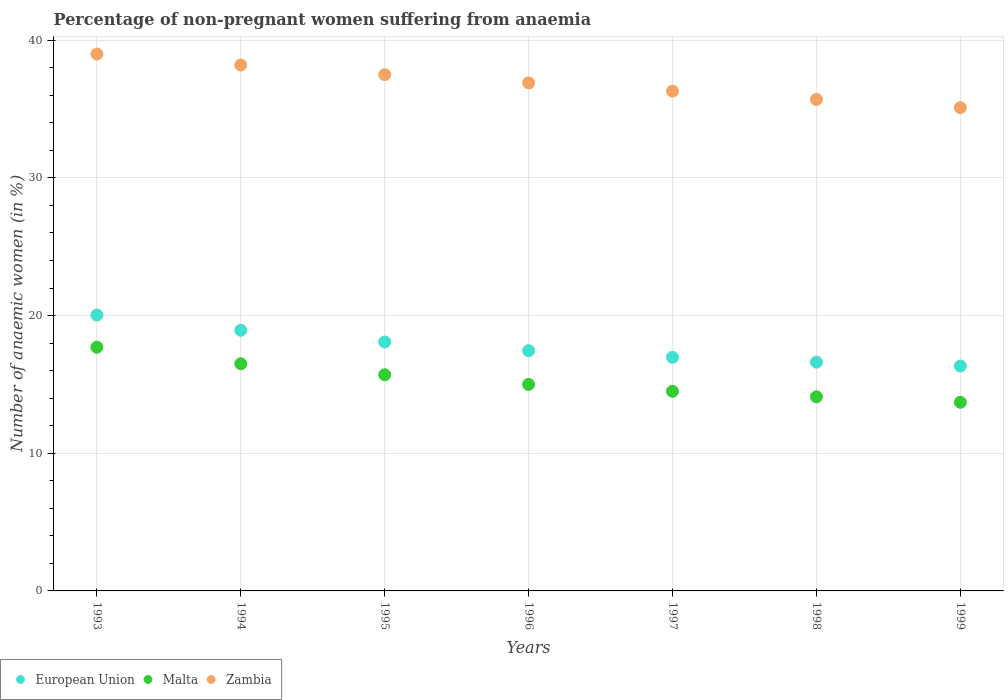How many different coloured dotlines are there?
Provide a succinct answer. 3. Is the number of dotlines equal to the number of legend labels?
Give a very brief answer. Yes. What is the percentage of non-pregnant women suffering from anaemia in Zambia in 1996?
Give a very brief answer. 36.9. Across all years, what is the minimum percentage of non-pregnant women suffering from anaemia in European Union?
Your response must be concise. 16.34. In which year was the percentage of non-pregnant women suffering from anaemia in Malta minimum?
Offer a very short reply. 1999. What is the total percentage of non-pregnant women suffering from anaemia in Zambia in the graph?
Offer a terse response. 258.7. What is the difference between the percentage of non-pregnant women suffering from anaemia in Malta in 1993 and that in 1997?
Provide a succinct answer. 3.2. What is the difference between the percentage of non-pregnant women suffering from anaemia in Malta in 1998 and the percentage of non-pregnant women suffering from anaemia in Zambia in 1996?
Provide a succinct answer. -22.8. What is the average percentage of non-pregnant women suffering from anaemia in Malta per year?
Offer a terse response. 15.31. In the year 1994, what is the difference between the percentage of non-pregnant women suffering from anaemia in Malta and percentage of non-pregnant women suffering from anaemia in Zambia?
Your response must be concise. -21.7. What is the ratio of the percentage of non-pregnant women suffering from anaemia in Malta in 1998 to that in 1999?
Provide a succinct answer. 1.03. Is the percentage of non-pregnant women suffering from anaemia in Zambia in 1996 less than that in 1999?
Offer a very short reply. No. Is the difference between the percentage of non-pregnant women suffering from anaemia in Malta in 1996 and 1999 greater than the difference between the percentage of non-pregnant women suffering from anaemia in Zambia in 1996 and 1999?
Ensure brevity in your answer.  No. What is the difference between the highest and the second highest percentage of non-pregnant women suffering from anaemia in Zambia?
Your response must be concise. 0.8. What is the difference between the highest and the lowest percentage of non-pregnant women suffering from anaemia in European Union?
Offer a terse response. 3.7. In how many years, is the percentage of non-pregnant women suffering from anaemia in European Union greater than the average percentage of non-pregnant women suffering from anaemia in European Union taken over all years?
Ensure brevity in your answer.  3. Is the sum of the percentage of non-pregnant women suffering from anaemia in European Union in 1995 and 1999 greater than the maximum percentage of non-pregnant women suffering from anaemia in Zambia across all years?
Your answer should be compact. No. Is it the case that in every year, the sum of the percentage of non-pregnant women suffering from anaemia in Zambia and percentage of non-pregnant women suffering from anaemia in Malta  is greater than the percentage of non-pregnant women suffering from anaemia in European Union?
Provide a succinct answer. Yes. Does the percentage of non-pregnant women suffering from anaemia in European Union monotonically increase over the years?
Offer a very short reply. No. Is the percentage of non-pregnant women suffering from anaemia in Zambia strictly less than the percentage of non-pregnant women suffering from anaemia in Malta over the years?
Your answer should be compact. No. How many dotlines are there?
Your answer should be very brief. 3. What is the difference between two consecutive major ticks on the Y-axis?
Offer a terse response. 10. Does the graph contain grids?
Your response must be concise. Yes. How many legend labels are there?
Make the answer very short. 3. What is the title of the graph?
Keep it short and to the point. Percentage of non-pregnant women suffering from anaemia. Does "Eritrea" appear as one of the legend labels in the graph?
Offer a very short reply. No. What is the label or title of the Y-axis?
Offer a terse response. Number of anaemic women (in %). What is the Number of anaemic women (in %) in European Union in 1993?
Your answer should be very brief. 20.04. What is the Number of anaemic women (in %) in Malta in 1993?
Provide a short and direct response. 17.7. What is the Number of anaemic women (in %) in European Union in 1994?
Provide a succinct answer. 18.93. What is the Number of anaemic women (in %) of Zambia in 1994?
Offer a terse response. 38.2. What is the Number of anaemic women (in %) in European Union in 1995?
Make the answer very short. 18.08. What is the Number of anaemic women (in %) of Zambia in 1995?
Give a very brief answer. 37.5. What is the Number of anaemic women (in %) in European Union in 1996?
Ensure brevity in your answer.  17.45. What is the Number of anaemic women (in %) of Malta in 1996?
Provide a short and direct response. 15. What is the Number of anaemic women (in %) of Zambia in 1996?
Offer a very short reply. 36.9. What is the Number of anaemic women (in %) in European Union in 1997?
Ensure brevity in your answer.  16.97. What is the Number of anaemic women (in %) of Zambia in 1997?
Give a very brief answer. 36.3. What is the Number of anaemic women (in %) in European Union in 1998?
Provide a succinct answer. 16.62. What is the Number of anaemic women (in %) in Malta in 1998?
Provide a short and direct response. 14.1. What is the Number of anaemic women (in %) in Zambia in 1998?
Ensure brevity in your answer.  35.7. What is the Number of anaemic women (in %) in European Union in 1999?
Provide a short and direct response. 16.34. What is the Number of anaemic women (in %) of Malta in 1999?
Offer a terse response. 13.7. What is the Number of anaemic women (in %) of Zambia in 1999?
Provide a succinct answer. 35.1. Across all years, what is the maximum Number of anaemic women (in %) in European Union?
Provide a succinct answer. 20.04. Across all years, what is the minimum Number of anaemic women (in %) in European Union?
Give a very brief answer. 16.34. Across all years, what is the minimum Number of anaemic women (in %) in Zambia?
Your answer should be very brief. 35.1. What is the total Number of anaemic women (in %) of European Union in the graph?
Offer a terse response. 124.42. What is the total Number of anaemic women (in %) of Malta in the graph?
Your answer should be very brief. 107.2. What is the total Number of anaemic women (in %) in Zambia in the graph?
Provide a short and direct response. 258.7. What is the difference between the Number of anaemic women (in %) in European Union in 1993 and that in 1994?
Provide a short and direct response. 1.11. What is the difference between the Number of anaemic women (in %) in Malta in 1993 and that in 1994?
Offer a very short reply. 1.2. What is the difference between the Number of anaemic women (in %) in European Union in 1993 and that in 1995?
Provide a succinct answer. 1.96. What is the difference between the Number of anaemic women (in %) in Malta in 1993 and that in 1995?
Ensure brevity in your answer.  2. What is the difference between the Number of anaemic women (in %) in European Union in 1993 and that in 1996?
Your answer should be very brief. 2.59. What is the difference between the Number of anaemic women (in %) in Malta in 1993 and that in 1996?
Offer a terse response. 2.7. What is the difference between the Number of anaemic women (in %) in European Union in 1993 and that in 1997?
Your response must be concise. 3.07. What is the difference between the Number of anaemic women (in %) in Zambia in 1993 and that in 1997?
Provide a short and direct response. 2.7. What is the difference between the Number of anaemic women (in %) of European Union in 1993 and that in 1998?
Provide a short and direct response. 3.42. What is the difference between the Number of anaemic women (in %) in European Union in 1993 and that in 1999?
Offer a terse response. 3.7. What is the difference between the Number of anaemic women (in %) in Malta in 1993 and that in 1999?
Ensure brevity in your answer.  4. What is the difference between the Number of anaemic women (in %) of European Union in 1994 and that in 1995?
Provide a short and direct response. 0.85. What is the difference between the Number of anaemic women (in %) in Malta in 1994 and that in 1995?
Ensure brevity in your answer.  0.8. What is the difference between the Number of anaemic women (in %) in Zambia in 1994 and that in 1995?
Provide a short and direct response. 0.7. What is the difference between the Number of anaemic women (in %) in European Union in 1994 and that in 1996?
Offer a very short reply. 1.48. What is the difference between the Number of anaemic women (in %) in Malta in 1994 and that in 1996?
Provide a succinct answer. 1.5. What is the difference between the Number of anaemic women (in %) of European Union in 1994 and that in 1997?
Provide a succinct answer. 1.97. What is the difference between the Number of anaemic women (in %) of European Union in 1994 and that in 1998?
Your answer should be compact. 2.32. What is the difference between the Number of anaemic women (in %) in Malta in 1994 and that in 1998?
Provide a short and direct response. 2.4. What is the difference between the Number of anaemic women (in %) of Zambia in 1994 and that in 1998?
Keep it short and to the point. 2.5. What is the difference between the Number of anaemic women (in %) in European Union in 1994 and that in 1999?
Your response must be concise. 2.6. What is the difference between the Number of anaemic women (in %) in Malta in 1994 and that in 1999?
Give a very brief answer. 2.8. What is the difference between the Number of anaemic women (in %) of Zambia in 1994 and that in 1999?
Offer a very short reply. 3.1. What is the difference between the Number of anaemic women (in %) in European Union in 1995 and that in 1996?
Your response must be concise. 0.63. What is the difference between the Number of anaemic women (in %) of European Union in 1995 and that in 1997?
Offer a very short reply. 1.12. What is the difference between the Number of anaemic women (in %) in Malta in 1995 and that in 1997?
Your response must be concise. 1.2. What is the difference between the Number of anaemic women (in %) of European Union in 1995 and that in 1998?
Provide a short and direct response. 1.46. What is the difference between the Number of anaemic women (in %) in European Union in 1995 and that in 1999?
Your response must be concise. 1.75. What is the difference between the Number of anaemic women (in %) of Malta in 1995 and that in 1999?
Keep it short and to the point. 2. What is the difference between the Number of anaemic women (in %) in Zambia in 1995 and that in 1999?
Give a very brief answer. 2.4. What is the difference between the Number of anaemic women (in %) in European Union in 1996 and that in 1997?
Offer a very short reply. 0.48. What is the difference between the Number of anaemic women (in %) in Malta in 1996 and that in 1997?
Offer a very short reply. 0.5. What is the difference between the Number of anaemic women (in %) in Zambia in 1996 and that in 1997?
Your response must be concise. 0.6. What is the difference between the Number of anaemic women (in %) of European Union in 1996 and that in 1998?
Offer a terse response. 0.83. What is the difference between the Number of anaemic women (in %) of Zambia in 1996 and that in 1998?
Your answer should be very brief. 1.2. What is the difference between the Number of anaemic women (in %) of European Union in 1996 and that in 1999?
Provide a succinct answer. 1.11. What is the difference between the Number of anaemic women (in %) of European Union in 1997 and that in 1998?
Your answer should be very brief. 0.35. What is the difference between the Number of anaemic women (in %) of Zambia in 1997 and that in 1998?
Keep it short and to the point. 0.6. What is the difference between the Number of anaemic women (in %) of European Union in 1997 and that in 1999?
Keep it short and to the point. 0.63. What is the difference between the Number of anaemic women (in %) of Zambia in 1997 and that in 1999?
Your answer should be compact. 1.2. What is the difference between the Number of anaemic women (in %) in European Union in 1998 and that in 1999?
Provide a succinct answer. 0.28. What is the difference between the Number of anaemic women (in %) of Malta in 1998 and that in 1999?
Ensure brevity in your answer.  0.4. What is the difference between the Number of anaemic women (in %) in Zambia in 1998 and that in 1999?
Provide a short and direct response. 0.6. What is the difference between the Number of anaemic women (in %) of European Union in 1993 and the Number of anaemic women (in %) of Malta in 1994?
Offer a terse response. 3.54. What is the difference between the Number of anaemic women (in %) in European Union in 1993 and the Number of anaemic women (in %) in Zambia in 1994?
Your response must be concise. -18.16. What is the difference between the Number of anaemic women (in %) of Malta in 1993 and the Number of anaemic women (in %) of Zambia in 1994?
Ensure brevity in your answer.  -20.5. What is the difference between the Number of anaemic women (in %) of European Union in 1993 and the Number of anaemic women (in %) of Malta in 1995?
Keep it short and to the point. 4.34. What is the difference between the Number of anaemic women (in %) in European Union in 1993 and the Number of anaemic women (in %) in Zambia in 1995?
Provide a succinct answer. -17.46. What is the difference between the Number of anaemic women (in %) of Malta in 1993 and the Number of anaemic women (in %) of Zambia in 1995?
Make the answer very short. -19.8. What is the difference between the Number of anaemic women (in %) of European Union in 1993 and the Number of anaemic women (in %) of Malta in 1996?
Make the answer very short. 5.04. What is the difference between the Number of anaemic women (in %) in European Union in 1993 and the Number of anaemic women (in %) in Zambia in 1996?
Your answer should be very brief. -16.86. What is the difference between the Number of anaemic women (in %) of Malta in 1993 and the Number of anaemic women (in %) of Zambia in 1996?
Provide a succinct answer. -19.2. What is the difference between the Number of anaemic women (in %) in European Union in 1993 and the Number of anaemic women (in %) in Malta in 1997?
Make the answer very short. 5.54. What is the difference between the Number of anaemic women (in %) of European Union in 1993 and the Number of anaemic women (in %) of Zambia in 1997?
Offer a terse response. -16.26. What is the difference between the Number of anaemic women (in %) of Malta in 1993 and the Number of anaemic women (in %) of Zambia in 1997?
Your response must be concise. -18.6. What is the difference between the Number of anaemic women (in %) in European Union in 1993 and the Number of anaemic women (in %) in Malta in 1998?
Make the answer very short. 5.94. What is the difference between the Number of anaemic women (in %) in European Union in 1993 and the Number of anaemic women (in %) in Zambia in 1998?
Offer a very short reply. -15.66. What is the difference between the Number of anaemic women (in %) in Malta in 1993 and the Number of anaemic women (in %) in Zambia in 1998?
Your answer should be very brief. -18. What is the difference between the Number of anaemic women (in %) in European Union in 1993 and the Number of anaemic women (in %) in Malta in 1999?
Provide a short and direct response. 6.34. What is the difference between the Number of anaemic women (in %) in European Union in 1993 and the Number of anaemic women (in %) in Zambia in 1999?
Offer a terse response. -15.06. What is the difference between the Number of anaemic women (in %) in Malta in 1993 and the Number of anaemic women (in %) in Zambia in 1999?
Offer a terse response. -17.4. What is the difference between the Number of anaemic women (in %) in European Union in 1994 and the Number of anaemic women (in %) in Malta in 1995?
Your response must be concise. 3.23. What is the difference between the Number of anaemic women (in %) in European Union in 1994 and the Number of anaemic women (in %) in Zambia in 1995?
Provide a succinct answer. -18.57. What is the difference between the Number of anaemic women (in %) in Malta in 1994 and the Number of anaemic women (in %) in Zambia in 1995?
Provide a short and direct response. -21. What is the difference between the Number of anaemic women (in %) of European Union in 1994 and the Number of anaemic women (in %) of Malta in 1996?
Your answer should be very brief. 3.93. What is the difference between the Number of anaemic women (in %) in European Union in 1994 and the Number of anaemic women (in %) in Zambia in 1996?
Provide a succinct answer. -17.97. What is the difference between the Number of anaemic women (in %) in Malta in 1994 and the Number of anaemic women (in %) in Zambia in 1996?
Offer a terse response. -20.4. What is the difference between the Number of anaemic women (in %) in European Union in 1994 and the Number of anaemic women (in %) in Malta in 1997?
Make the answer very short. 4.43. What is the difference between the Number of anaemic women (in %) in European Union in 1994 and the Number of anaemic women (in %) in Zambia in 1997?
Give a very brief answer. -17.37. What is the difference between the Number of anaemic women (in %) in Malta in 1994 and the Number of anaemic women (in %) in Zambia in 1997?
Your response must be concise. -19.8. What is the difference between the Number of anaemic women (in %) of European Union in 1994 and the Number of anaemic women (in %) of Malta in 1998?
Keep it short and to the point. 4.83. What is the difference between the Number of anaemic women (in %) in European Union in 1994 and the Number of anaemic women (in %) in Zambia in 1998?
Provide a succinct answer. -16.77. What is the difference between the Number of anaemic women (in %) in Malta in 1994 and the Number of anaemic women (in %) in Zambia in 1998?
Your answer should be compact. -19.2. What is the difference between the Number of anaemic women (in %) of European Union in 1994 and the Number of anaemic women (in %) of Malta in 1999?
Your answer should be compact. 5.23. What is the difference between the Number of anaemic women (in %) of European Union in 1994 and the Number of anaemic women (in %) of Zambia in 1999?
Give a very brief answer. -16.17. What is the difference between the Number of anaemic women (in %) of Malta in 1994 and the Number of anaemic women (in %) of Zambia in 1999?
Your answer should be very brief. -18.6. What is the difference between the Number of anaemic women (in %) of European Union in 1995 and the Number of anaemic women (in %) of Malta in 1996?
Your response must be concise. 3.08. What is the difference between the Number of anaemic women (in %) in European Union in 1995 and the Number of anaemic women (in %) in Zambia in 1996?
Offer a terse response. -18.82. What is the difference between the Number of anaemic women (in %) of Malta in 1995 and the Number of anaemic women (in %) of Zambia in 1996?
Provide a short and direct response. -21.2. What is the difference between the Number of anaemic women (in %) of European Union in 1995 and the Number of anaemic women (in %) of Malta in 1997?
Keep it short and to the point. 3.58. What is the difference between the Number of anaemic women (in %) in European Union in 1995 and the Number of anaemic women (in %) in Zambia in 1997?
Provide a short and direct response. -18.22. What is the difference between the Number of anaemic women (in %) of Malta in 1995 and the Number of anaemic women (in %) of Zambia in 1997?
Keep it short and to the point. -20.6. What is the difference between the Number of anaemic women (in %) in European Union in 1995 and the Number of anaemic women (in %) in Malta in 1998?
Your answer should be very brief. 3.98. What is the difference between the Number of anaemic women (in %) in European Union in 1995 and the Number of anaemic women (in %) in Zambia in 1998?
Give a very brief answer. -17.62. What is the difference between the Number of anaemic women (in %) in European Union in 1995 and the Number of anaemic women (in %) in Malta in 1999?
Give a very brief answer. 4.38. What is the difference between the Number of anaemic women (in %) in European Union in 1995 and the Number of anaemic women (in %) in Zambia in 1999?
Your answer should be compact. -17.02. What is the difference between the Number of anaemic women (in %) of Malta in 1995 and the Number of anaemic women (in %) of Zambia in 1999?
Your response must be concise. -19.4. What is the difference between the Number of anaemic women (in %) of European Union in 1996 and the Number of anaemic women (in %) of Malta in 1997?
Provide a short and direct response. 2.95. What is the difference between the Number of anaemic women (in %) of European Union in 1996 and the Number of anaemic women (in %) of Zambia in 1997?
Your response must be concise. -18.85. What is the difference between the Number of anaemic women (in %) in Malta in 1996 and the Number of anaemic women (in %) in Zambia in 1997?
Your answer should be compact. -21.3. What is the difference between the Number of anaemic women (in %) in European Union in 1996 and the Number of anaemic women (in %) in Malta in 1998?
Keep it short and to the point. 3.35. What is the difference between the Number of anaemic women (in %) of European Union in 1996 and the Number of anaemic women (in %) of Zambia in 1998?
Provide a succinct answer. -18.25. What is the difference between the Number of anaemic women (in %) of Malta in 1996 and the Number of anaemic women (in %) of Zambia in 1998?
Provide a succinct answer. -20.7. What is the difference between the Number of anaemic women (in %) of European Union in 1996 and the Number of anaemic women (in %) of Malta in 1999?
Keep it short and to the point. 3.75. What is the difference between the Number of anaemic women (in %) of European Union in 1996 and the Number of anaemic women (in %) of Zambia in 1999?
Keep it short and to the point. -17.65. What is the difference between the Number of anaemic women (in %) of Malta in 1996 and the Number of anaemic women (in %) of Zambia in 1999?
Offer a terse response. -20.1. What is the difference between the Number of anaemic women (in %) of European Union in 1997 and the Number of anaemic women (in %) of Malta in 1998?
Offer a terse response. 2.87. What is the difference between the Number of anaemic women (in %) in European Union in 1997 and the Number of anaemic women (in %) in Zambia in 1998?
Give a very brief answer. -18.73. What is the difference between the Number of anaemic women (in %) in Malta in 1997 and the Number of anaemic women (in %) in Zambia in 1998?
Provide a succinct answer. -21.2. What is the difference between the Number of anaemic women (in %) in European Union in 1997 and the Number of anaemic women (in %) in Malta in 1999?
Your answer should be compact. 3.27. What is the difference between the Number of anaemic women (in %) of European Union in 1997 and the Number of anaemic women (in %) of Zambia in 1999?
Your answer should be compact. -18.13. What is the difference between the Number of anaemic women (in %) of Malta in 1997 and the Number of anaemic women (in %) of Zambia in 1999?
Offer a terse response. -20.6. What is the difference between the Number of anaemic women (in %) in European Union in 1998 and the Number of anaemic women (in %) in Malta in 1999?
Make the answer very short. 2.92. What is the difference between the Number of anaemic women (in %) of European Union in 1998 and the Number of anaemic women (in %) of Zambia in 1999?
Your answer should be very brief. -18.48. What is the average Number of anaemic women (in %) of European Union per year?
Make the answer very short. 17.77. What is the average Number of anaemic women (in %) of Malta per year?
Offer a very short reply. 15.31. What is the average Number of anaemic women (in %) of Zambia per year?
Give a very brief answer. 36.96. In the year 1993, what is the difference between the Number of anaemic women (in %) of European Union and Number of anaemic women (in %) of Malta?
Provide a succinct answer. 2.34. In the year 1993, what is the difference between the Number of anaemic women (in %) in European Union and Number of anaemic women (in %) in Zambia?
Your answer should be compact. -18.96. In the year 1993, what is the difference between the Number of anaemic women (in %) of Malta and Number of anaemic women (in %) of Zambia?
Ensure brevity in your answer.  -21.3. In the year 1994, what is the difference between the Number of anaemic women (in %) of European Union and Number of anaemic women (in %) of Malta?
Your response must be concise. 2.43. In the year 1994, what is the difference between the Number of anaemic women (in %) in European Union and Number of anaemic women (in %) in Zambia?
Your response must be concise. -19.27. In the year 1994, what is the difference between the Number of anaemic women (in %) in Malta and Number of anaemic women (in %) in Zambia?
Make the answer very short. -21.7. In the year 1995, what is the difference between the Number of anaemic women (in %) of European Union and Number of anaemic women (in %) of Malta?
Offer a very short reply. 2.38. In the year 1995, what is the difference between the Number of anaemic women (in %) in European Union and Number of anaemic women (in %) in Zambia?
Offer a terse response. -19.42. In the year 1995, what is the difference between the Number of anaemic women (in %) in Malta and Number of anaemic women (in %) in Zambia?
Provide a succinct answer. -21.8. In the year 1996, what is the difference between the Number of anaemic women (in %) of European Union and Number of anaemic women (in %) of Malta?
Give a very brief answer. 2.45. In the year 1996, what is the difference between the Number of anaemic women (in %) of European Union and Number of anaemic women (in %) of Zambia?
Give a very brief answer. -19.45. In the year 1996, what is the difference between the Number of anaemic women (in %) in Malta and Number of anaemic women (in %) in Zambia?
Provide a short and direct response. -21.9. In the year 1997, what is the difference between the Number of anaemic women (in %) in European Union and Number of anaemic women (in %) in Malta?
Offer a very short reply. 2.47. In the year 1997, what is the difference between the Number of anaemic women (in %) in European Union and Number of anaemic women (in %) in Zambia?
Offer a terse response. -19.33. In the year 1997, what is the difference between the Number of anaemic women (in %) of Malta and Number of anaemic women (in %) of Zambia?
Your answer should be very brief. -21.8. In the year 1998, what is the difference between the Number of anaemic women (in %) in European Union and Number of anaemic women (in %) in Malta?
Provide a short and direct response. 2.52. In the year 1998, what is the difference between the Number of anaemic women (in %) of European Union and Number of anaemic women (in %) of Zambia?
Your response must be concise. -19.08. In the year 1998, what is the difference between the Number of anaemic women (in %) in Malta and Number of anaemic women (in %) in Zambia?
Make the answer very short. -21.6. In the year 1999, what is the difference between the Number of anaemic women (in %) in European Union and Number of anaemic women (in %) in Malta?
Ensure brevity in your answer.  2.64. In the year 1999, what is the difference between the Number of anaemic women (in %) of European Union and Number of anaemic women (in %) of Zambia?
Your response must be concise. -18.76. In the year 1999, what is the difference between the Number of anaemic women (in %) in Malta and Number of anaemic women (in %) in Zambia?
Your response must be concise. -21.4. What is the ratio of the Number of anaemic women (in %) of European Union in 1993 to that in 1994?
Give a very brief answer. 1.06. What is the ratio of the Number of anaemic women (in %) in Malta in 1993 to that in 1994?
Give a very brief answer. 1.07. What is the ratio of the Number of anaemic women (in %) of Zambia in 1993 to that in 1994?
Your answer should be compact. 1.02. What is the ratio of the Number of anaemic women (in %) of European Union in 1993 to that in 1995?
Give a very brief answer. 1.11. What is the ratio of the Number of anaemic women (in %) in Malta in 1993 to that in 1995?
Provide a short and direct response. 1.13. What is the ratio of the Number of anaemic women (in %) in Zambia in 1993 to that in 1995?
Provide a short and direct response. 1.04. What is the ratio of the Number of anaemic women (in %) in European Union in 1993 to that in 1996?
Provide a succinct answer. 1.15. What is the ratio of the Number of anaemic women (in %) of Malta in 1993 to that in 1996?
Give a very brief answer. 1.18. What is the ratio of the Number of anaemic women (in %) in Zambia in 1993 to that in 1996?
Keep it short and to the point. 1.06. What is the ratio of the Number of anaemic women (in %) in European Union in 1993 to that in 1997?
Offer a terse response. 1.18. What is the ratio of the Number of anaemic women (in %) in Malta in 1993 to that in 1997?
Make the answer very short. 1.22. What is the ratio of the Number of anaemic women (in %) in Zambia in 1993 to that in 1997?
Your answer should be very brief. 1.07. What is the ratio of the Number of anaemic women (in %) in European Union in 1993 to that in 1998?
Keep it short and to the point. 1.21. What is the ratio of the Number of anaemic women (in %) in Malta in 1993 to that in 1998?
Your answer should be compact. 1.26. What is the ratio of the Number of anaemic women (in %) of Zambia in 1993 to that in 1998?
Your answer should be compact. 1.09. What is the ratio of the Number of anaemic women (in %) of European Union in 1993 to that in 1999?
Provide a succinct answer. 1.23. What is the ratio of the Number of anaemic women (in %) in Malta in 1993 to that in 1999?
Provide a succinct answer. 1.29. What is the ratio of the Number of anaemic women (in %) of European Union in 1994 to that in 1995?
Offer a very short reply. 1.05. What is the ratio of the Number of anaemic women (in %) in Malta in 1994 to that in 1995?
Your answer should be very brief. 1.05. What is the ratio of the Number of anaemic women (in %) of Zambia in 1994 to that in 1995?
Your answer should be compact. 1.02. What is the ratio of the Number of anaemic women (in %) of European Union in 1994 to that in 1996?
Ensure brevity in your answer.  1.09. What is the ratio of the Number of anaemic women (in %) in Zambia in 1994 to that in 1996?
Give a very brief answer. 1.04. What is the ratio of the Number of anaemic women (in %) in European Union in 1994 to that in 1997?
Your response must be concise. 1.12. What is the ratio of the Number of anaemic women (in %) in Malta in 1994 to that in 1997?
Provide a short and direct response. 1.14. What is the ratio of the Number of anaemic women (in %) in Zambia in 1994 to that in 1997?
Give a very brief answer. 1.05. What is the ratio of the Number of anaemic women (in %) in European Union in 1994 to that in 1998?
Give a very brief answer. 1.14. What is the ratio of the Number of anaemic women (in %) in Malta in 1994 to that in 1998?
Offer a very short reply. 1.17. What is the ratio of the Number of anaemic women (in %) of Zambia in 1994 to that in 1998?
Your answer should be compact. 1.07. What is the ratio of the Number of anaemic women (in %) of European Union in 1994 to that in 1999?
Make the answer very short. 1.16. What is the ratio of the Number of anaemic women (in %) in Malta in 1994 to that in 1999?
Make the answer very short. 1.2. What is the ratio of the Number of anaemic women (in %) of Zambia in 1994 to that in 1999?
Ensure brevity in your answer.  1.09. What is the ratio of the Number of anaemic women (in %) of European Union in 1995 to that in 1996?
Make the answer very short. 1.04. What is the ratio of the Number of anaemic women (in %) of Malta in 1995 to that in 1996?
Your answer should be compact. 1.05. What is the ratio of the Number of anaemic women (in %) in Zambia in 1995 to that in 1996?
Make the answer very short. 1.02. What is the ratio of the Number of anaemic women (in %) in European Union in 1995 to that in 1997?
Provide a succinct answer. 1.07. What is the ratio of the Number of anaemic women (in %) in Malta in 1995 to that in 1997?
Provide a short and direct response. 1.08. What is the ratio of the Number of anaemic women (in %) of Zambia in 1995 to that in 1997?
Your answer should be very brief. 1.03. What is the ratio of the Number of anaemic women (in %) in European Union in 1995 to that in 1998?
Offer a terse response. 1.09. What is the ratio of the Number of anaemic women (in %) in Malta in 1995 to that in 1998?
Ensure brevity in your answer.  1.11. What is the ratio of the Number of anaemic women (in %) of Zambia in 1995 to that in 1998?
Offer a terse response. 1.05. What is the ratio of the Number of anaemic women (in %) in European Union in 1995 to that in 1999?
Provide a short and direct response. 1.11. What is the ratio of the Number of anaemic women (in %) in Malta in 1995 to that in 1999?
Ensure brevity in your answer.  1.15. What is the ratio of the Number of anaemic women (in %) of Zambia in 1995 to that in 1999?
Ensure brevity in your answer.  1.07. What is the ratio of the Number of anaemic women (in %) in European Union in 1996 to that in 1997?
Give a very brief answer. 1.03. What is the ratio of the Number of anaemic women (in %) of Malta in 1996 to that in 1997?
Offer a terse response. 1.03. What is the ratio of the Number of anaemic women (in %) of Zambia in 1996 to that in 1997?
Ensure brevity in your answer.  1.02. What is the ratio of the Number of anaemic women (in %) in Malta in 1996 to that in 1998?
Your answer should be compact. 1.06. What is the ratio of the Number of anaemic women (in %) of Zambia in 1996 to that in 1998?
Your answer should be compact. 1.03. What is the ratio of the Number of anaemic women (in %) of European Union in 1996 to that in 1999?
Provide a succinct answer. 1.07. What is the ratio of the Number of anaemic women (in %) in Malta in 1996 to that in 1999?
Offer a very short reply. 1.09. What is the ratio of the Number of anaemic women (in %) of Zambia in 1996 to that in 1999?
Ensure brevity in your answer.  1.05. What is the ratio of the Number of anaemic women (in %) of European Union in 1997 to that in 1998?
Ensure brevity in your answer.  1.02. What is the ratio of the Number of anaemic women (in %) in Malta in 1997 to that in 1998?
Provide a short and direct response. 1.03. What is the ratio of the Number of anaemic women (in %) in Zambia in 1997 to that in 1998?
Provide a succinct answer. 1.02. What is the ratio of the Number of anaemic women (in %) of European Union in 1997 to that in 1999?
Give a very brief answer. 1.04. What is the ratio of the Number of anaemic women (in %) of Malta in 1997 to that in 1999?
Your response must be concise. 1.06. What is the ratio of the Number of anaemic women (in %) in Zambia in 1997 to that in 1999?
Ensure brevity in your answer.  1.03. What is the ratio of the Number of anaemic women (in %) in European Union in 1998 to that in 1999?
Provide a short and direct response. 1.02. What is the ratio of the Number of anaemic women (in %) of Malta in 1998 to that in 1999?
Provide a succinct answer. 1.03. What is the ratio of the Number of anaemic women (in %) in Zambia in 1998 to that in 1999?
Keep it short and to the point. 1.02. What is the difference between the highest and the second highest Number of anaemic women (in %) of European Union?
Give a very brief answer. 1.11. What is the difference between the highest and the second highest Number of anaemic women (in %) in Malta?
Your response must be concise. 1.2. What is the difference between the highest and the second highest Number of anaemic women (in %) of Zambia?
Ensure brevity in your answer.  0.8. What is the difference between the highest and the lowest Number of anaemic women (in %) in European Union?
Ensure brevity in your answer.  3.7. What is the difference between the highest and the lowest Number of anaemic women (in %) in Zambia?
Ensure brevity in your answer.  3.9. 